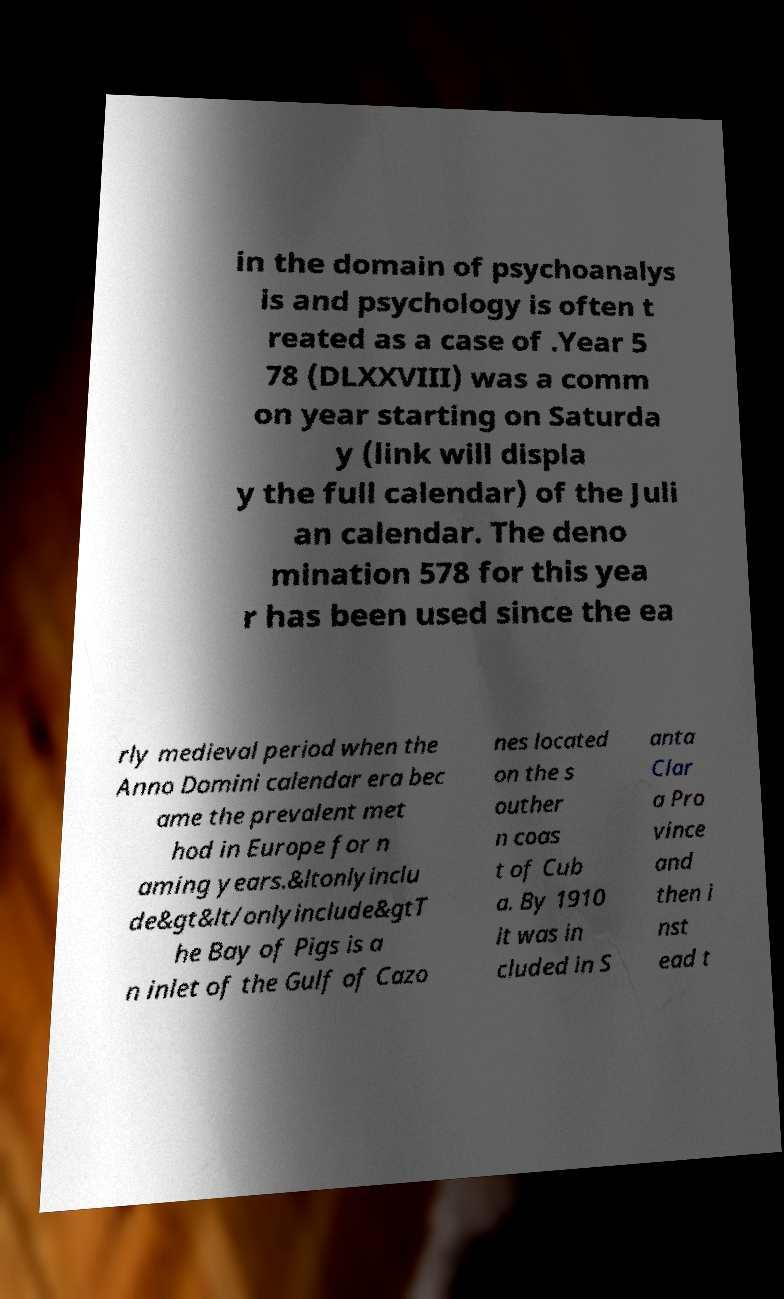What messages or text are displayed in this image? I need them in a readable, typed format. in the domain of psychoanalys is and psychology is often t reated as a case of .Year 5 78 (DLXXVIII) was a comm on year starting on Saturda y (link will displa y the full calendar) of the Juli an calendar. The deno mination 578 for this yea r has been used since the ea rly medieval period when the Anno Domini calendar era bec ame the prevalent met hod in Europe for n aming years.&ltonlyinclu de&gt&lt/onlyinclude&gtT he Bay of Pigs is a n inlet of the Gulf of Cazo nes located on the s outher n coas t of Cub a. By 1910 it was in cluded in S anta Clar a Pro vince and then i nst ead t 